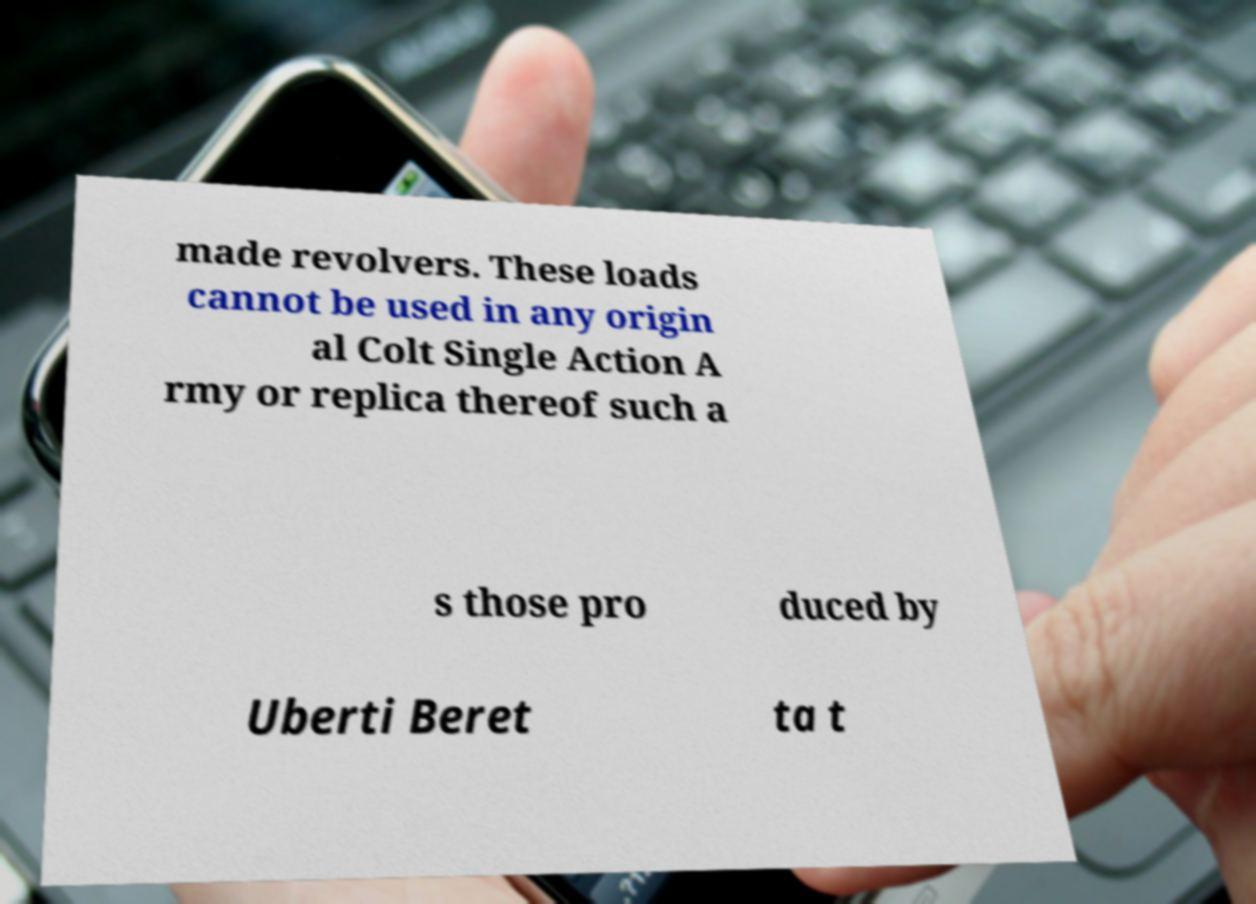Please read and relay the text visible in this image. What does it say? made revolvers. These loads cannot be used in any origin al Colt Single Action A rmy or replica thereof such a s those pro duced by Uberti Beret ta t 